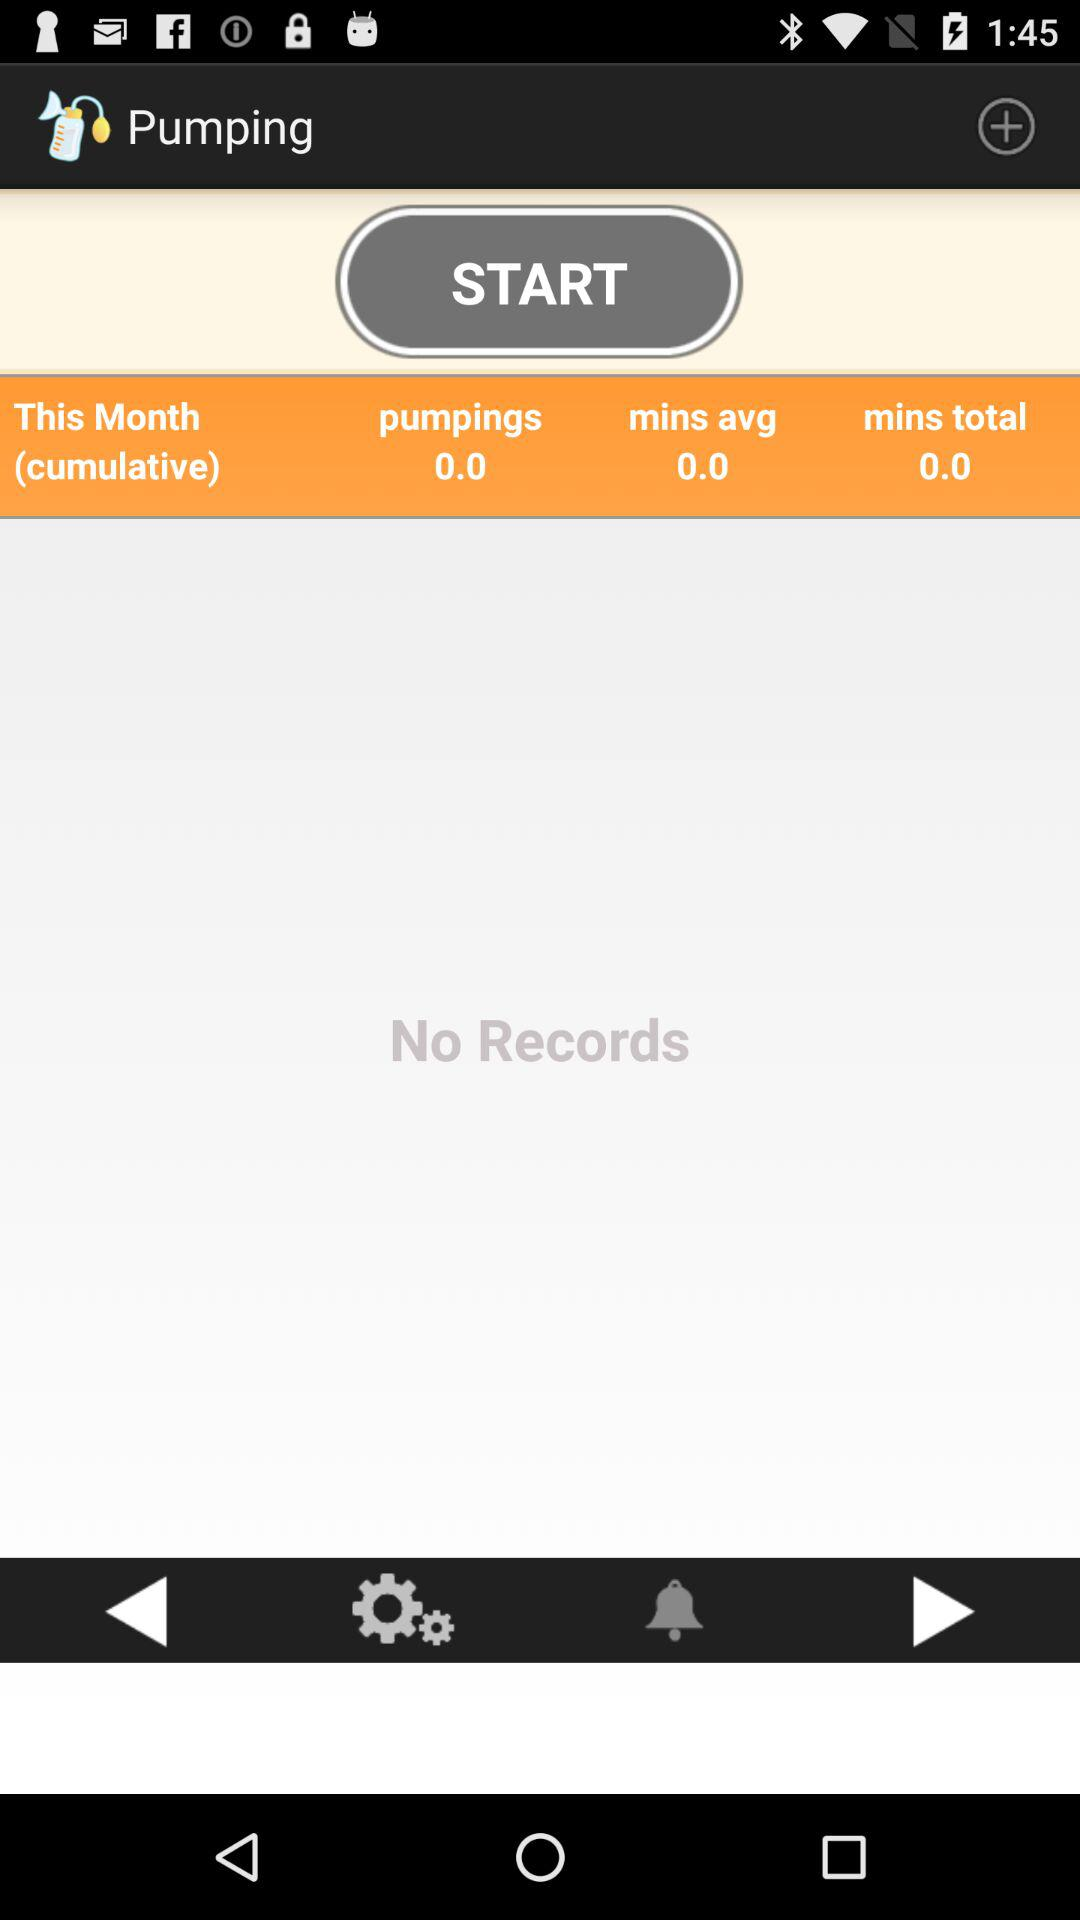What is the application name? The application name is "Pumping". 